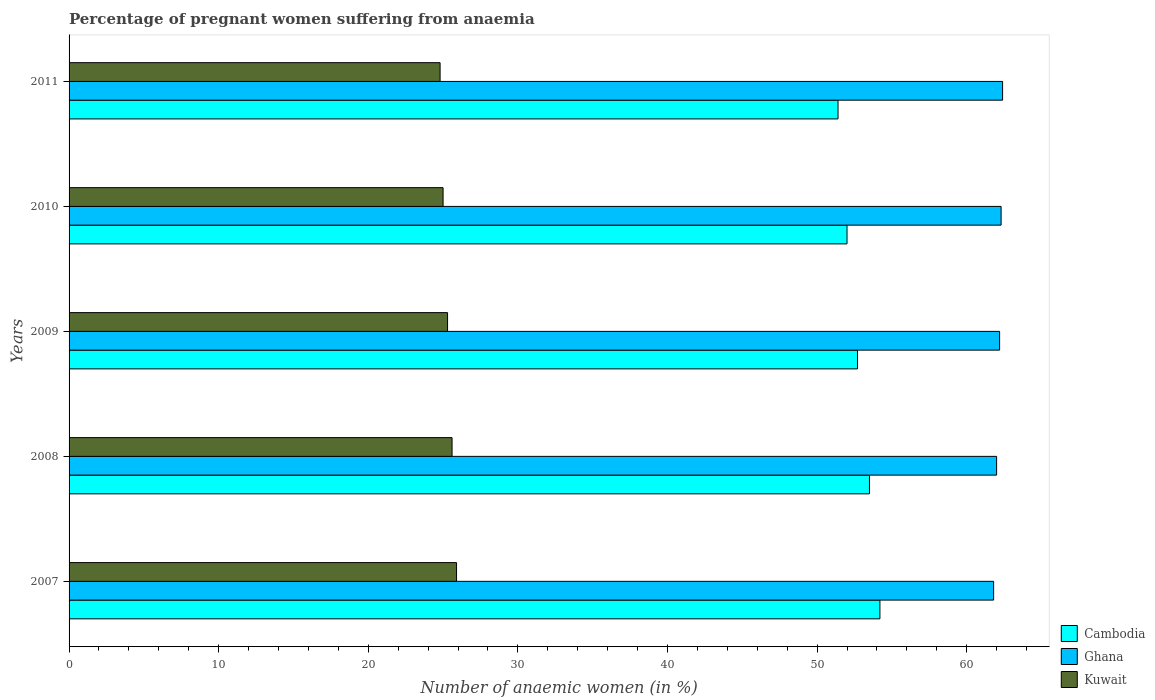Are the number of bars per tick equal to the number of legend labels?
Ensure brevity in your answer.  Yes. How many bars are there on the 1st tick from the top?
Your response must be concise. 3. How many bars are there on the 2nd tick from the bottom?
Keep it short and to the point. 3. Across all years, what is the maximum number of anaemic women in Cambodia?
Offer a very short reply. 54.2. Across all years, what is the minimum number of anaemic women in Ghana?
Your answer should be compact. 61.8. In which year was the number of anaemic women in Cambodia minimum?
Your answer should be very brief. 2011. What is the total number of anaemic women in Cambodia in the graph?
Your answer should be very brief. 263.8. What is the difference between the number of anaemic women in Cambodia in 2008 and that in 2009?
Provide a short and direct response. 0.8. What is the average number of anaemic women in Cambodia per year?
Offer a very short reply. 52.76. In the year 2007, what is the difference between the number of anaemic women in Ghana and number of anaemic women in Cambodia?
Your answer should be compact. 7.6. In how many years, is the number of anaemic women in Cambodia greater than 56 %?
Keep it short and to the point. 0. What is the ratio of the number of anaemic women in Kuwait in 2008 to that in 2009?
Make the answer very short. 1.01. Is the number of anaemic women in Kuwait in 2009 less than that in 2011?
Offer a terse response. No. Is the difference between the number of anaemic women in Ghana in 2007 and 2008 greater than the difference between the number of anaemic women in Cambodia in 2007 and 2008?
Make the answer very short. No. What is the difference between the highest and the second highest number of anaemic women in Cambodia?
Provide a short and direct response. 0.7. What is the difference between the highest and the lowest number of anaemic women in Kuwait?
Your response must be concise. 1.1. What does the 2nd bar from the top in 2008 represents?
Provide a short and direct response. Ghana. What does the 2nd bar from the bottom in 2011 represents?
Ensure brevity in your answer.  Ghana. Is it the case that in every year, the sum of the number of anaemic women in Kuwait and number of anaemic women in Cambodia is greater than the number of anaemic women in Ghana?
Your answer should be very brief. Yes. Are all the bars in the graph horizontal?
Provide a short and direct response. Yes. What is the difference between two consecutive major ticks on the X-axis?
Offer a terse response. 10. Are the values on the major ticks of X-axis written in scientific E-notation?
Offer a very short reply. No. Does the graph contain any zero values?
Offer a very short reply. No. Does the graph contain grids?
Provide a succinct answer. No. How are the legend labels stacked?
Provide a succinct answer. Vertical. What is the title of the graph?
Your answer should be compact. Percentage of pregnant women suffering from anaemia. Does "Puerto Rico" appear as one of the legend labels in the graph?
Keep it short and to the point. No. What is the label or title of the X-axis?
Your answer should be very brief. Number of anaemic women (in %). What is the label or title of the Y-axis?
Keep it short and to the point. Years. What is the Number of anaemic women (in %) in Cambodia in 2007?
Give a very brief answer. 54.2. What is the Number of anaemic women (in %) in Ghana in 2007?
Provide a succinct answer. 61.8. What is the Number of anaemic women (in %) of Kuwait in 2007?
Provide a succinct answer. 25.9. What is the Number of anaemic women (in %) of Cambodia in 2008?
Make the answer very short. 53.5. What is the Number of anaemic women (in %) of Ghana in 2008?
Make the answer very short. 62. What is the Number of anaemic women (in %) in Kuwait in 2008?
Provide a short and direct response. 25.6. What is the Number of anaemic women (in %) in Cambodia in 2009?
Give a very brief answer. 52.7. What is the Number of anaemic women (in %) in Ghana in 2009?
Give a very brief answer. 62.2. What is the Number of anaemic women (in %) of Kuwait in 2009?
Your answer should be compact. 25.3. What is the Number of anaemic women (in %) of Ghana in 2010?
Your answer should be compact. 62.3. What is the Number of anaemic women (in %) in Kuwait in 2010?
Make the answer very short. 25. What is the Number of anaemic women (in %) of Cambodia in 2011?
Provide a short and direct response. 51.4. What is the Number of anaemic women (in %) of Ghana in 2011?
Give a very brief answer. 62.4. What is the Number of anaemic women (in %) in Kuwait in 2011?
Give a very brief answer. 24.8. Across all years, what is the maximum Number of anaemic women (in %) in Cambodia?
Make the answer very short. 54.2. Across all years, what is the maximum Number of anaemic women (in %) of Ghana?
Your response must be concise. 62.4. Across all years, what is the maximum Number of anaemic women (in %) in Kuwait?
Give a very brief answer. 25.9. Across all years, what is the minimum Number of anaemic women (in %) in Cambodia?
Provide a succinct answer. 51.4. Across all years, what is the minimum Number of anaemic women (in %) of Ghana?
Offer a very short reply. 61.8. Across all years, what is the minimum Number of anaemic women (in %) in Kuwait?
Ensure brevity in your answer.  24.8. What is the total Number of anaemic women (in %) of Cambodia in the graph?
Your answer should be very brief. 263.8. What is the total Number of anaemic women (in %) in Ghana in the graph?
Provide a short and direct response. 310.7. What is the total Number of anaemic women (in %) in Kuwait in the graph?
Provide a succinct answer. 126.6. What is the difference between the Number of anaemic women (in %) in Kuwait in 2007 and that in 2008?
Give a very brief answer. 0.3. What is the difference between the Number of anaemic women (in %) of Cambodia in 2007 and that in 2009?
Give a very brief answer. 1.5. What is the difference between the Number of anaemic women (in %) in Kuwait in 2007 and that in 2010?
Offer a terse response. 0.9. What is the difference between the Number of anaemic women (in %) in Ghana in 2007 and that in 2011?
Ensure brevity in your answer.  -0.6. What is the difference between the Number of anaemic women (in %) of Kuwait in 2007 and that in 2011?
Your answer should be compact. 1.1. What is the difference between the Number of anaemic women (in %) of Kuwait in 2008 and that in 2009?
Your answer should be compact. 0.3. What is the difference between the Number of anaemic women (in %) of Cambodia in 2008 and that in 2010?
Offer a terse response. 1.5. What is the difference between the Number of anaemic women (in %) in Ghana in 2008 and that in 2010?
Offer a terse response. -0.3. What is the difference between the Number of anaemic women (in %) in Kuwait in 2008 and that in 2010?
Provide a short and direct response. 0.6. What is the difference between the Number of anaemic women (in %) in Cambodia in 2008 and that in 2011?
Make the answer very short. 2.1. What is the difference between the Number of anaemic women (in %) of Ghana in 2008 and that in 2011?
Give a very brief answer. -0.4. What is the difference between the Number of anaemic women (in %) of Ghana in 2009 and that in 2010?
Make the answer very short. -0.1. What is the difference between the Number of anaemic women (in %) in Kuwait in 2009 and that in 2010?
Provide a short and direct response. 0.3. What is the difference between the Number of anaemic women (in %) of Cambodia in 2009 and that in 2011?
Ensure brevity in your answer.  1.3. What is the difference between the Number of anaemic women (in %) of Kuwait in 2009 and that in 2011?
Give a very brief answer. 0.5. What is the difference between the Number of anaemic women (in %) in Cambodia in 2010 and that in 2011?
Give a very brief answer. 0.6. What is the difference between the Number of anaemic women (in %) of Kuwait in 2010 and that in 2011?
Provide a succinct answer. 0.2. What is the difference between the Number of anaemic women (in %) in Cambodia in 2007 and the Number of anaemic women (in %) in Ghana in 2008?
Offer a very short reply. -7.8. What is the difference between the Number of anaemic women (in %) in Cambodia in 2007 and the Number of anaemic women (in %) in Kuwait in 2008?
Make the answer very short. 28.6. What is the difference between the Number of anaemic women (in %) in Ghana in 2007 and the Number of anaemic women (in %) in Kuwait in 2008?
Your response must be concise. 36.2. What is the difference between the Number of anaemic women (in %) of Cambodia in 2007 and the Number of anaemic women (in %) of Kuwait in 2009?
Provide a succinct answer. 28.9. What is the difference between the Number of anaemic women (in %) of Ghana in 2007 and the Number of anaemic women (in %) of Kuwait in 2009?
Keep it short and to the point. 36.5. What is the difference between the Number of anaemic women (in %) of Cambodia in 2007 and the Number of anaemic women (in %) of Ghana in 2010?
Provide a succinct answer. -8.1. What is the difference between the Number of anaemic women (in %) in Cambodia in 2007 and the Number of anaemic women (in %) in Kuwait in 2010?
Your answer should be compact. 29.2. What is the difference between the Number of anaemic women (in %) in Ghana in 2007 and the Number of anaemic women (in %) in Kuwait in 2010?
Your answer should be very brief. 36.8. What is the difference between the Number of anaemic women (in %) of Cambodia in 2007 and the Number of anaemic women (in %) of Kuwait in 2011?
Your answer should be compact. 29.4. What is the difference between the Number of anaemic women (in %) of Cambodia in 2008 and the Number of anaemic women (in %) of Ghana in 2009?
Provide a short and direct response. -8.7. What is the difference between the Number of anaemic women (in %) of Cambodia in 2008 and the Number of anaemic women (in %) of Kuwait in 2009?
Your response must be concise. 28.2. What is the difference between the Number of anaemic women (in %) of Ghana in 2008 and the Number of anaemic women (in %) of Kuwait in 2009?
Your response must be concise. 36.7. What is the difference between the Number of anaemic women (in %) of Cambodia in 2008 and the Number of anaemic women (in %) of Ghana in 2010?
Offer a terse response. -8.8. What is the difference between the Number of anaemic women (in %) of Ghana in 2008 and the Number of anaemic women (in %) of Kuwait in 2010?
Make the answer very short. 37. What is the difference between the Number of anaemic women (in %) of Cambodia in 2008 and the Number of anaemic women (in %) of Kuwait in 2011?
Your response must be concise. 28.7. What is the difference between the Number of anaemic women (in %) of Ghana in 2008 and the Number of anaemic women (in %) of Kuwait in 2011?
Keep it short and to the point. 37.2. What is the difference between the Number of anaemic women (in %) in Cambodia in 2009 and the Number of anaemic women (in %) in Kuwait in 2010?
Your answer should be compact. 27.7. What is the difference between the Number of anaemic women (in %) of Ghana in 2009 and the Number of anaemic women (in %) of Kuwait in 2010?
Offer a very short reply. 37.2. What is the difference between the Number of anaemic women (in %) of Cambodia in 2009 and the Number of anaemic women (in %) of Ghana in 2011?
Ensure brevity in your answer.  -9.7. What is the difference between the Number of anaemic women (in %) of Cambodia in 2009 and the Number of anaemic women (in %) of Kuwait in 2011?
Make the answer very short. 27.9. What is the difference between the Number of anaemic women (in %) of Ghana in 2009 and the Number of anaemic women (in %) of Kuwait in 2011?
Your response must be concise. 37.4. What is the difference between the Number of anaemic women (in %) in Cambodia in 2010 and the Number of anaemic women (in %) in Ghana in 2011?
Your answer should be compact. -10.4. What is the difference between the Number of anaemic women (in %) of Cambodia in 2010 and the Number of anaemic women (in %) of Kuwait in 2011?
Your response must be concise. 27.2. What is the difference between the Number of anaemic women (in %) of Ghana in 2010 and the Number of anaemic women (in %) of Kuwait in 2011?
Make the answer very short. 37.5. What is the average Number of anaemic women (in %) of Cambodia per year?
Ensure brevity in your answer.  52.76. What is the average Number of anaemic women (in %) of Ghana per year?
Your response must be concise. 62.14. What is the average Number of anaemic women (in %) in Kuwait per year?
Make the answer very short. 25.32. In the year 2007, what is the difference between the Number of anaemic women (in %) in Cambodia and Number of anaemic women (in %) in Kuwait?
Provide a succinct answer. 28.3. In the year 2007, what is the difference between the Number of anaemic women (in %) of Ghana and Number of anaemic women (in %) of Kuwait?
Your response must be concise. 35.9. In the year 2008, what is the difference between the Number of anaemic women (in %) of Cambodia and Number of anaemic women (in %) of Kuwait?
Make the answer very short. 27.9. In the year 2008, what is the difference between the Number of anaemic women (in %) of Ghana and Number of anaemic women (in %) of Kuwait?
Make the answer very short. 36.4. In the year 2009, what is the difference between the Number of anaemic women (in %) in Cambodia and Number of anaemic women (in %) in Kuwait?
Offer a terse response. 27.4. In the year 2009, what is the difference between the Number of anaemic women (in %) in Ghana and Number of anaemic women (in %) in Kuwait?
Ensure brevity in your answer.  36.9. In the year 2010, what is the difference between the Number of anaemic women (in %) in Cambodia and Number of anaemic women (in %) in Ghana?
Give a very brief answer. -10.3. In the year 2010, what is the difference between the Number of anaemic women (in %) of Cambodia and Number of anaemic women (in %) of Kuwait?
Offer a terse response. 27. In the year 2010, what is the difference between the Number of anaemic women (in %) in Ghana and Number of anaemic women (in %) in Kuwait?
Give a very brief answer. 37.3. In the year 2011, what is the difference between the Number of anaemic women (in %) in Cambodia and Number of anaemic women (in %) in Ghana?
Make the answer very short. -11. In the year 2011, what is the difference between the Number of anaemic women (in %) in Cambodia and Number of anaemic women (in %) in Kuwait?
Provide a succinct answer. 26.6. In the year 2011, what is the difference between the Number of anaemic women (in %) in Ghana and Number of anaemic women (in %) in Kuwait?
Your answer should be compact. 37.6. What is the ratio of the Number of anaemic women (in %) of Cambodia in 2007 to that in 2008?
Make the answer very short. 1.01. What is the ratio of the Number of anaemic women (in %) in Kuwait in 2007 to that in 2008?
Offer a very short reply. 1.01. What is the ratio of the Number of anaemic women (in %) of Cambodia in 2007 to that in 2009?
Your answer should be compact. 1.03. What is the ratio of the Number of anaemic women (in %) in Kuwait in 2007 to that in 2009?
Keep it short and to the point. 1.02. What is the ratio of the Number of anaemic women (in %) in Cambodia in 2007 to that in 2010?
Keep it short and to the point. 1.04. What is the ratio of the Number of anaemic women (in %) of Ghana in 2007 to that in 2010?
Provide a short and direct response. 0.99. What is the ratio of the Number of anaemic women (in %) of Kuwait in 2007 to that in 2010?
Keep it short and to the point. 1.04. What is the ratio of the Number of anaemic women (in %) of Cambodia in 2007 to that in 2011?
Provide a short and direct response. 1.05. What is the ratio of the Number of anaemic women (in %) in Ghana in 2007 to that in 2011?
Ensure brevity in your answer.  0.99. What is the ratio of the Number of anaemic women (in %) of Kuwait in 2007 to that in 2011?
Ensure brevity in your answer.  1.04. What is the ratio of the Number of anaemic women (in %) of Cambodia in 2008 to that in 2009?
Make the answer very short. 1.02. What is the ratio of the Number of anaemic women (in %) in Ghana in 2008 to that in 2009?
Your response must be concise. 1. What is the ratio of the Number of anaemic women (in %) in Kuwait in 2008 to that in 2009?
Provide a succinct answer. 1.01. What is the ratio of the Number of anaemic women (in %) in Cambodia in 2008 to that in 2010?
Give a very brief answer. 1.03. What is the ratio of the Number of anaemic women (in %) of Ghana in 2008 to that in 2010?
Provide a short and direct response. 1. What is the ratio of the Number of anaemic women (in %) of Cambodia in 2008 to that in 2011?
Provide a succinct answer. 1.04. What is the ratio of the Number of anaemic women (in %) of Ghana in 2008 to that in 2011?
Keep it short and to the point. 0.99. What is the ratio of the Number of anaemic women (in %) in Kuwait in 2008 to that in 2011?
Keep it short and to the point. 1.03. What is the ratio of the Number of anaemic women (in %) of Cambodia in 2009 to that in 2010?
Your answer should be very brief. 1.01. What is the ratio of the Number of anaemic women (in %) of Kuwait in 2009 to that in 2010?
Provide a short and direct response. 1.01. What is the ratio of the Number of anaemic women (in %) in Cambodia in 2009 to that in 2011?
Ensure brevity in your answer.  1.03. What is the ratio of the Number of anaemic women (in %) of Ghana in 2009 to that in 2011?
Offer a very short reply. 1. What is the ratio of the Number of anaemic women (in %) of Kuwait in 2009 to that in 2011?
Ensure brevity in your answer.  1.02. What is the ratio of the Number of anaemic women (in %) in Cambodia in 2010 to that in 2011?
Your response must be concise. 1.01. What is the ratio of the Number of anaemic women (in %) in Ghana in 2010 to that in 2011?
Give a very brief answer. 1. What is the ratio of the Number of anaemic women (in %) of Kuwait in 2010 to that in 2011?
Ensure brevity in your answer.  1.01. What is the difference between the highest and the second highest Number of anaemic women (in %) of Cambodia?
Your response must be concise. 0.7. What is the difference between the highest and the second highest Number of anaemic women (in %) in Ghana?
Give a very brief answer. 0.1. What is the difference between the highest and the lowest Number of anaemic women (in %) in Cambodia?
Offer a very short reply. 2.8. What is the difference between the highest and the lowest Number of anaemic women (in %) in Kuwait?
Your answer should be very brief. 1.1. 